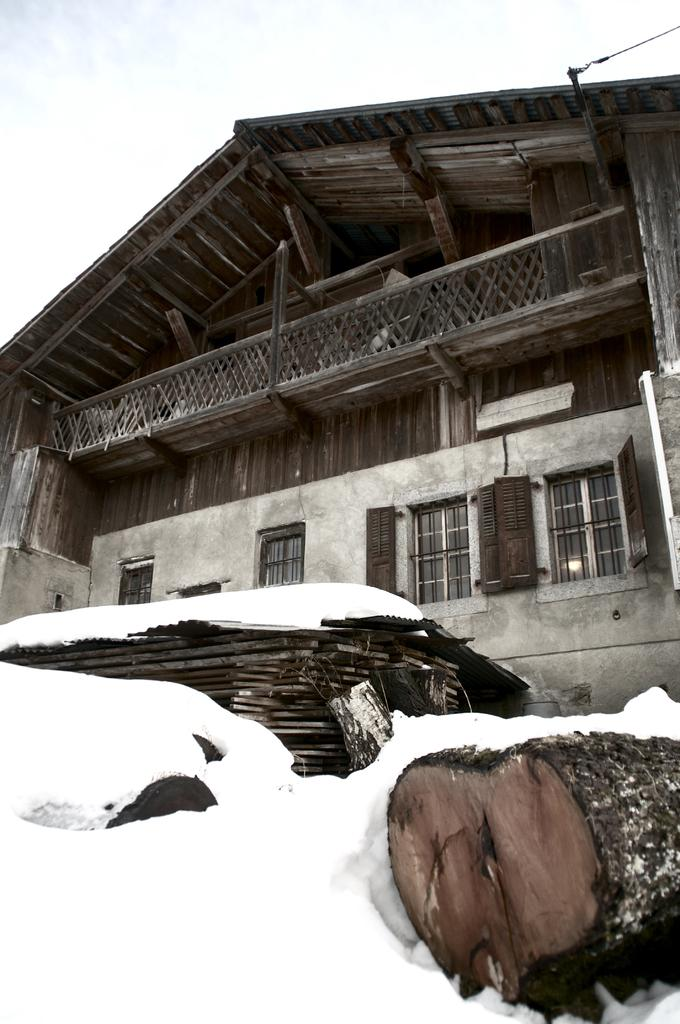What type of structure is visible in the picture? There is a house in the picture. What object is located in front of the house? There is a wooden object in front of the house. What can be seen at the top of the picture? The sky is visible at the top of the picture. What is the head of the thing doing in the picture? There is no head or thing present in the image. 